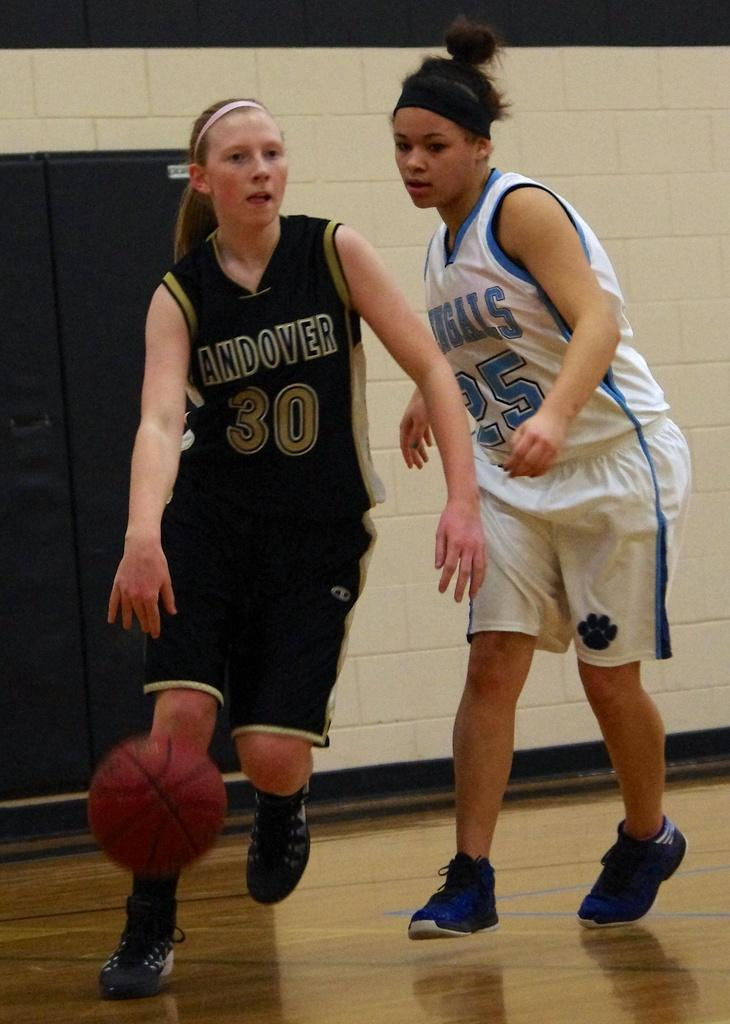<image>
Offer a succinct explanation of the picture presented. The player in black has the number 30 on her top. 